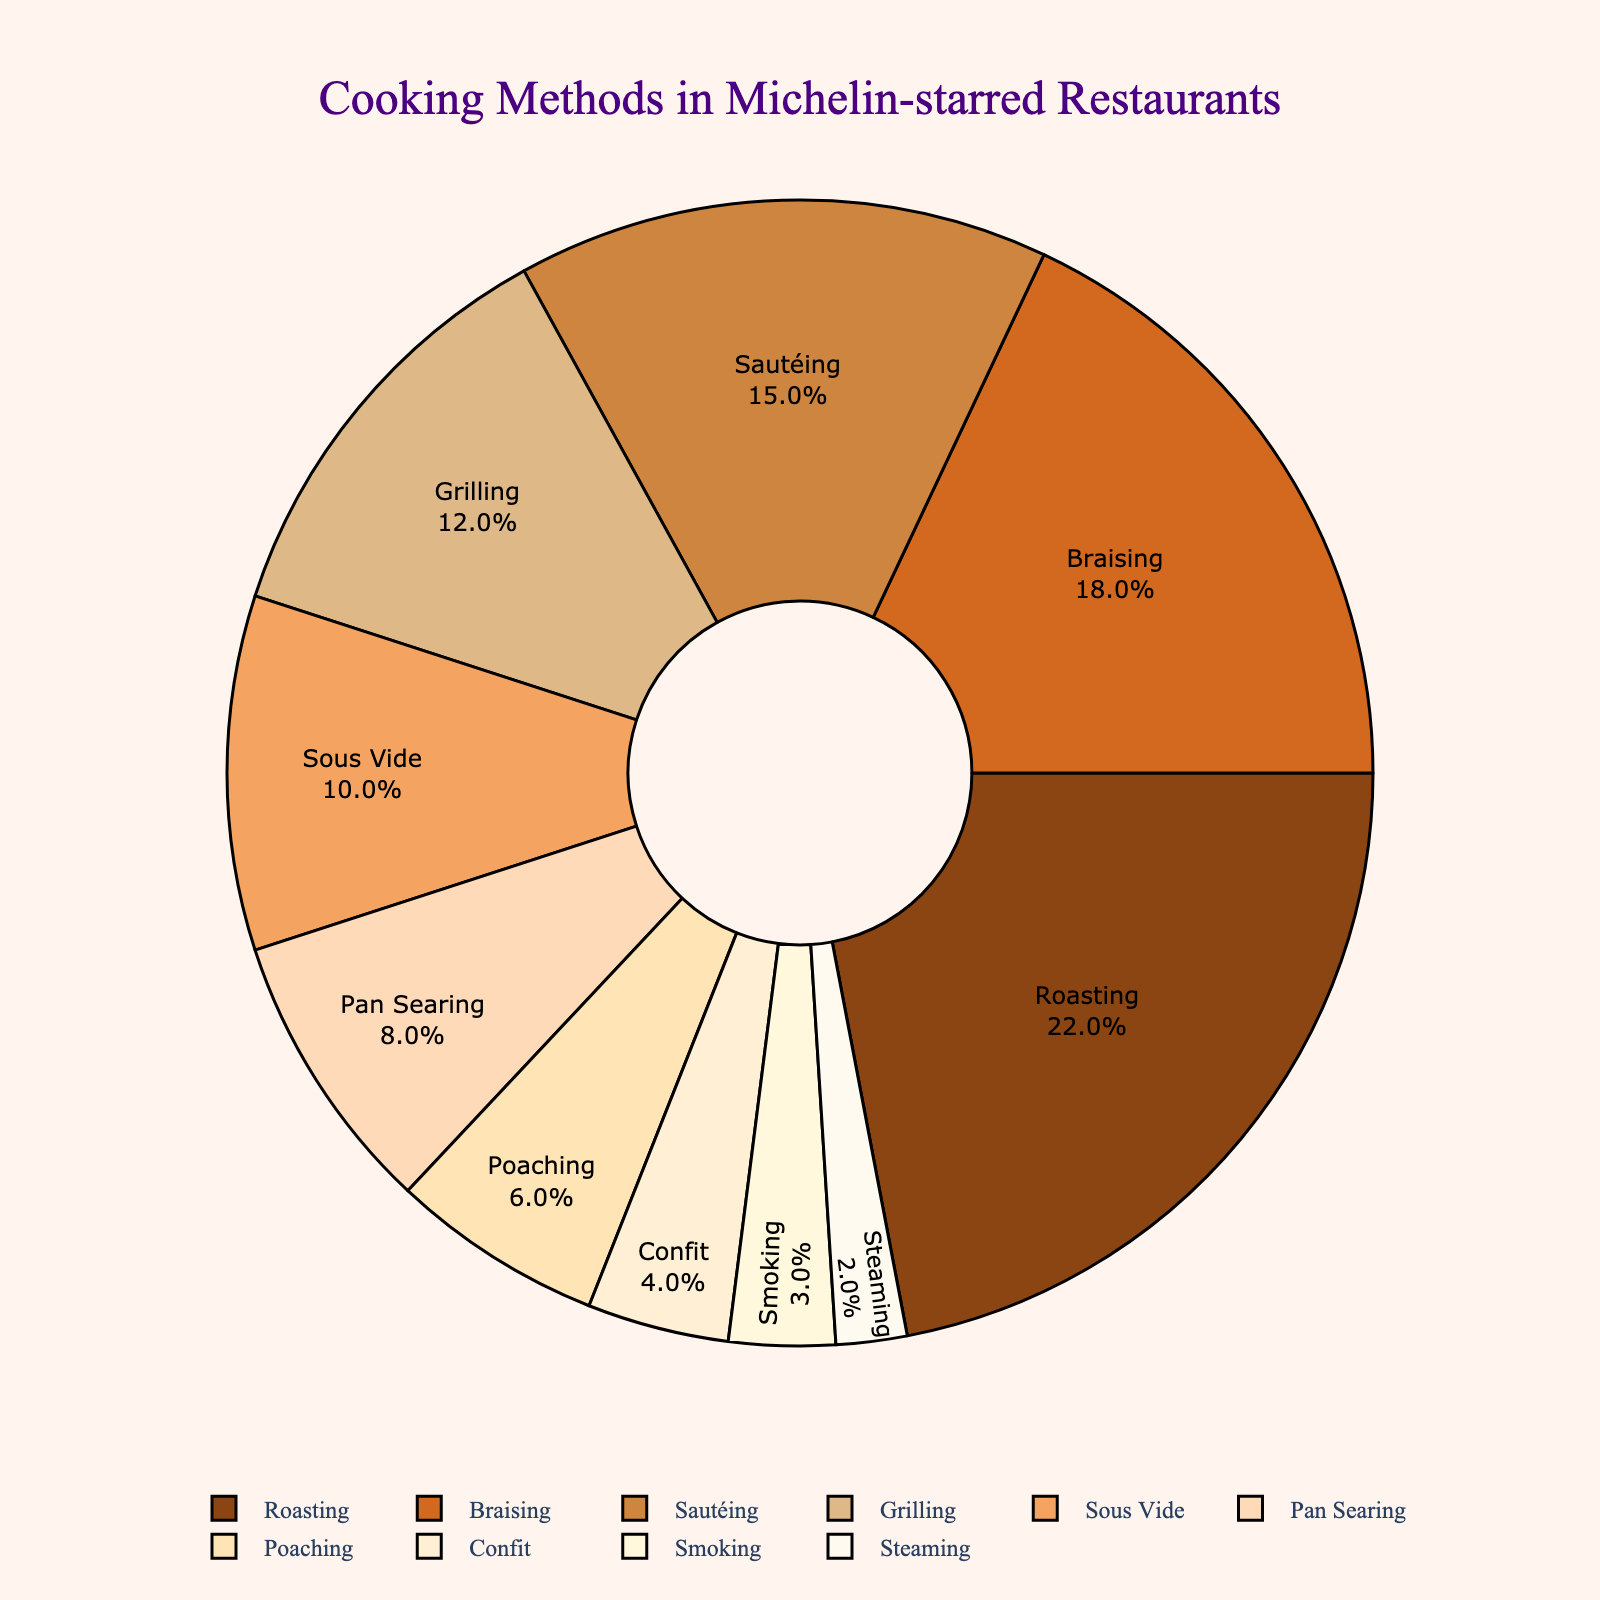What cooking method is used the most in Michelin-starred restaurants? The pie chart shows the percentage breakdown of cooking methods, and Roasting holds the highest percentage at 22%.
Answer: Roasting (22%) What is the combined percentage for Sous Vide and Pan Searing cooking methods? To find the combined percentage, add the percentages of Sous Vide and Pan Searing. Sous Vide is 10% and Pan Searing is 8%. Therefore, 10% + 8% = 18%.
Answer: 18% Which cooking method is used less frequently, Smoking or Steaming? The pie chart indicates the percentage breakdown, and Smoking is at 3% while Steaming is at 2%. Since 2% is less than 3%, Steaming is used less frequently.
Answer: Steaming (2%) Are there more Michelin-starred restaurants using Sautéing or Grilling? The pie chart shows that Sautéing accounts for 15% and Grilling accounts for 12%. Since 15% is greater than 12%, more restaurants use Sautéing.
Answer: Sautéing (15%) What is the total percentage of the three most commonly used cooking methods? Identify the three largest percentages from the chart: Roasting (22%), Braising (18%), and Sautéing (15%). Summing these, we get 22% + 18% + 15% = 55%.
Answer: 55% Is the percentage of Braising greater than twice the percentage of Smoking? Braising is 18% and Smoking is 3%. Twice the percentage of Smoking is 3% * 2 = 6%. Since 18% > 6%, Braising exceeds twice the percentage of Smoking.
Answer: Yes What is the difference in percentage between Poaching and Confit? The pie chart shows Poaching at 6% and Confit at 4%. The difference is 6% - 4% = 2%.
Answer: 2% If another method is introduced that equals the percentage of Confit, what will be the new total percentage of all methods? Currently, the total is 100%. Adding a new method equal to Confit's 4% would make the total 100% + 4% = 104%.
Answer: 104% What percentage of the cooking methods fall under the category of "low usage" (5% or less)? Identify methods with 5% or less: Poaching (6% is excluded), Confit (4%), Smoking (3%), and Steaming (2%). Add these: 4% + 3% + 2% = 9%.
Answer: 9% How much more is the percentage of Braising compared to Sautéing? The chart shows Braising at 18% and Sautéing at 15%. The difference is 18% - 15% = 3%.
Answer: 3% 